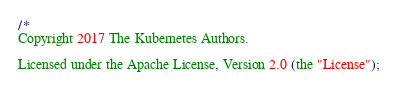Convert code to text. <code><loc_0><loc_0><loc_500><loc_500><_Go_>/*
Copyright 2017 The Kubernetes Authors.

Licensed under the Apache License, Version 2.0 (the "License");</code> 